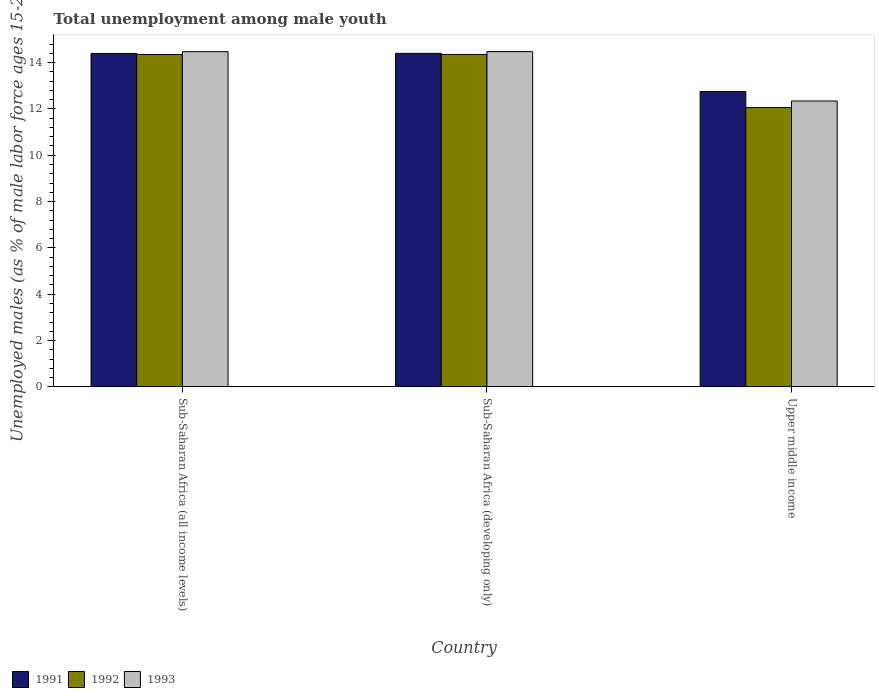How many groups of bars are there?
Your answer should be very brief. 3. How many bars are there on the 2nd tick from the right?
Your answer should be very brief. 3. What is the label of the 2nd group of bars from the left?
Your answer should be compact. Sub-Saharan Africa (developing only). In how many cases, is the number of bars for a given country not equal to the number of legend labels?
Give a very brief answer. 0. What is the percentage of unemployed males in in 1993 in Sub-Saharan Africa (developing only)?
Ensure brevity in your answer.  14.47. Across all countries, what is the maximum percentage of unemployed males in in 1991?
Your answer should be very brief. 14.4. Across all countries, what is the minimum percentage of unemployed males in in 1991?
Offer a terse response. 12.75. In which country was the percentage of unemployed males in in 1992 maximum?
Your answer should be compact. Sub-Saharan Africa (developing only). In which country was the percentage of unemployed males in in 1992 minimum?
Your answer should be very brief. Upper middle income. What is the total percentage of unemployed males in in 1991 in the graph?
Offer a very short reply. 41.55. What is the difference between the percentage of unemployed males in in 1993 in Sub-Saharan Africa (all income levels) and that in Upper middle income?
Make the answer very short. 2.13. What is the difference between the percentage of unemployed males in in 1993 in Sub-Saharan Africa (developing only) and the percentage of unemployed males in in 1991 in Upper middle income?
Provide a succinct answer. 1.72. What is the average percentage of unemployed males in in 1991 per country?
Offer a terse response. 13.85. What is the difference between the percentage of unemployed males in of/in 1993 and percentage of unemployed males in of/in 1992 in Sub-Saharan Africa (developing only)?
Your answer should be compact. 0.12. What is the ratio of the percentage of unemployed males in in 1992 in Sub-Saharan Africa (developing only) to that in Upper middle income?
Make the answer very short. 1.19. Is the percentage of unemployed males in in 1991 in Sub-Saharan Africa (all income levels) less than that in Sub-Saharan Africa (developing only)?
Make the answer very short. Yes. Is the difference between the percentage of unemployed males in in 1993 in Sub-Saharan Africa (all income levels) and Upper middle income greater than the difference between the percentage of unemployed males in in 1992 in Sub-Saharan Africa (all income levels) and Upper middle income?
Your answer should be very brief. No. What is the difference between the highest and the second highest percentage of unemployed males in in 1991?
Your response must be concise. -1.65. What is the difference between the highest and the lowest percentage of unemployed males in in 1991?
Provide a short and direct response. 1.65. In how many countries, is the percentage of unemployed males in in 1993 greater than the average percentage of unemployed males in in 1993 taken over all countries?
Keep it short and to the point. 2. Is the sum of the percentage of unemployed males in in 1991 in Sub-Saharan Africa (developing only) and Upper middle income greater than the maximum percentage of unemployed males in in 1993 across all countries?
Make the answer very short. Yes. Are all the bars in the graph horizontal?
Make the answer very short. No. What is the difference between two consecutive major ticks on the Y-axis?
Ensure brevity in your answer.  2. Does the graph contain any zero values?
Offer a very short reply. No. Does the graph contain grids?
Give a very brief answer. No. Where does the legend appear in the graph?
Ensure brevity in your answer.  Bottom left. How are the legend labels stacked?
Keep it short and to the point. Horizontal. What is the title of the graph?
Your response must be concise. Total unemployment among male youth. What is the label or title of the X-axis?
Give a very brief answer. Country. What is the label or title of the Y-axis?
Give a very brief answer. Unemployed males (as % of male labor force ages 15-24). What is the Unemployed males (as % of male labor force ages 15-24) in 1991 in Sub-Saharan Africa (all income levels)?
Offer a very short reply. 14.4. What is the Unemployed males (as % of male labor force ages 15-24) in 1992 in Sub-Saharan Africa (all income levels)?
Provide a short and direct response. 14.35. What is the Unemployed males (as % of male labor force ages 15-24) in 1993 in Sub-Saharan Africa (all income levels)?
Ensure brevity in your answer.  14.47. What is the Unemployed males (as % of male labor force ages 15-24) in 1991 in Sub-Saharan Africa (developing only)?
Ensure brevity in your answer.  14.4. What is the Unemployed males (as % of male labor force ages 15-24) of 1992 in Sub-Saharan Africa (developing only)?
Give a very brief answer. 14.35. What is the Unemployed males (as % of male labor force ages 15-24) in 1993 in Sub-Saharan Africa (developing only)?
Offer a very short reply. 14.47. What is the Unemployed males (as % of male labor force ages 15-24) in 1991 in Upper middle income?
Provide a short and direct response. 12.75. What is the Unemployed males (as % of male labor force ages 15-24) of 1992 in Upper middle income?
Give a very brief answer. 12.06. What is the Unemployed males (as % of male labor force ages 15-24) of 1993 in Upper middle income?
Your answer should be very brief. 12.34. Across all countries, what is the maximum Unemployed males (as % of male labor force ages 15-24) in 1991?
Your answer should be compact. 14.4. Across all countries, what is the maximum Unemployed males (as % of male labor force ages 15-24) in 1992?
Offer a terse response. 14.35. Across all countries, what is the maximum Unemployed males (as % of male labor force ages 15-24) of 1993?
Keep it short and to the point. 14.47. Across all countries, what is the minimum Unemployed males (as % of male labor force ages 15-24) of 1991?
Make the answer very short. 12.75. Across all countries, what is the minimum Unemployed males (as % of male labor force ages 15-24) of 1992?
Your response must be concise. 12.06. Across all countries, what is the minimum Unemployed males (as % of male labor force ages 15-24) of 1993?
Make the answer very short. 12.34. What is the total Unemployed males (as % of male labor force ages 15-24) in 1991 in the graph?
Offer a very short reply. 41.55. What is the total Unemployed males (as % of male labor force ages 15-24) of 1992 in the graph?
Provide a short and direct response. 40.76. What is the total Unemployed males (as % of male labor force ages 15-24) of 1993 in the graph?
Your answer should be compact. 41.29. What is the difference between the Unemployed males (as % of male labor force ages 15-24) in 1991 in Sub-Saharan Africa (all income levels) and that in Sub-Saharan Africa (developing only)?
Keep it short and to the point. -0. What is the difference between the Unemployed males (as % of male labor force ages 15-24) in 1992 in Sub-Saharan Africa (all income levels) and that in Sub-Saharan Africa (developing only)?
Keep it short and to the point. -0. What is the difference between the Unemployed males (as % of male labor force ages 15-24) in 1993 in Sub-Saharan Africa (all income levels) and that in Sub-Saharan Africa (developing only)?
Provide a short and direct response. -0. What is the difference between the Unemployed males (as % of male labor force ages 15-24) in 1991 in Sub-Saharan Africa (all income levels) and that in Upper middle income?
Offer a very short reply. 1.65. What is the difference between the Unemployed males (as % of male labor force ages 15-24) of 1992 in Sub-Saharan Africa (all income levels) and that in Upper middle income?
Provide a short and direct response. 2.29. What is the difference between the Unemployed males (as % of male labor force ages 15-24) of 1993 in Sub-Saharan Africa (all income levels) and that in Upper middle income?
Offer a very short reply. 2.13. What is the difference between the Unemployed males (as % of male labor force ages 15-24) in 1991 in Sub-Saharan Africa (developing only) and that in Upper middle income?
Provide a short and direct response. 1.65. What is the difference between the Unemployed males (as % of male labor force ages 15-24) in 1992 in Sub-Saharan Africa (developing only) and that in Upper middle income?
Provide a succinct answer. 2.29. What is the difference between the Unemployed males (as % of male labor force ages 15-24) in 1993 in Sub-Saharan Africa (developing only) and that in Upper middle income?
Make the answer very short. 2.13. What is the difference between the Unemployed males (as % of male labor force ages 15-24) in 1991 in Sub-Saharan Africa (all income levels) and the Unemployed males (as % of male labor force ages 15-24) in 1992 in Sub-Saharan Africa (developing only)?
Your answer should be very brief. 0.04. What is the difference between the Unemployed males (as % of male labor force ages 15-24) in 1991 in Sub-Saharan Africa (all income levels) and the Unemployed males (as % of male labor force ages 15-24) in 1993 in Sub-Saharan Africa (developing only)?
Provide a short and direct response. -0.08. What is the difference between the Unemployed males (as % of male labor force ages 15-24) of 1992 in Sub-Saharan Africa (all income levels) and the Unemployed males (as % of male labor force ages 15-24) of 1993 in Sub-Saharan Africa (developing only)?
Provide a short and direct response. -0.12. What is the difference between the Unemployed males (as % of male labor force ages 15-24) in 1991 in Sub-Saharan Africa (all income levels) and the Unemployed males (as % of male labor force ages 15-24) in 1992 in Upper middle income?
Ensure brevity in your answer.  2.34. What is the difference between the Unemployed males (as % of male labor force ages 15-24) in 1991 in Sub-Saharan Africa (all income levels) and the Unemployed males (as % of male labor force ages 15-24) in 1993 in Upper middle income?
Make the answer very short. 2.05. What is the difference between the Unemployed males (as % of male labor force ages 15-24) of 1992 in Sub-Saharan Africa (all income levels) and the Unemployed males (as % of male labor force ages 15-24) of 1993 in Upper middle income?
Keep it short and to the point. 2.01. What is the difference between the Unemployed males (as % of male labor force ages 15-24) in 1991 in Sub-Saharan Africa (developing only) and the Unemployed males (as % of male labor force ages 15-24) in 1992 in Upper middle income?
Provide a short and direct response. 2.34. What is the difference between the Unemployed males (as % of male labor force ages 15-24) in 1991 in Sub-Saharan Africa (developing only) and the Unemployed males (as % of male labor force ages 15-24) in 1993 in Upper middle income?
Offer a very short reply. 2.06. What is the difference between the Unemployed males (as % of male labor force ages 15-24) of 1992 in Sub-Saharan Africa (developing only) and the Unemployed males (as % of male labor force ages 15-24) of 1993 in Upper middle income?
Your response must be concise. 2.01. What is the average Unemployed males (as % of male labor force ages 15-24) in 1991 per country?
Make the answer very short. 13.85. What is the average Unemployed males (as % of male labor force ages 15-24) of 1992 per country?
Keep it short and to the point. 13.59. What is the average Unemployed males (as % of male labor force ages 15-24) of 1993 per country?
Provide a short and direct response. 13.76. What is the difference between the Unemployed males (as % of male labor force ages 15-24) of 1991 and Unemployed males (as % of male labor force ages 15-24) of 1992 in Sub-Saharan Africa (all income levels)?
Give a very brief answer. 0.05. What is the difference between the Unemployed males (as % of male labor force ages 15-24) in 1991 and Unemployed males (as % of male labor force ages 15-24) in 1993 in Sub-Saharan Africa (all income levels)?
Provide a short and direct response. -0.08. What is the difference between the Unemployed males (as % of male labor force ages 15-24) in 1992 and Unemployed males (as % of male labor force ages 15-24) in 1993 in Sub-Saharan Africa (all income levels)?
Your response must be concise. -0.12. What is the difference between the Unemployed males (as % of male labor force ages 15-24) of 1991 and Unemployed males (as % of male labor force ages 15-24) of 1992 in Sub-Saharan Africa (developing only)?
Keep it short and to the point. 0.05. What is the difference between the Unemployed males (as % of male labor force ages 15-24) in 1991 and Unemployed males (as % of male labor force ages 15-24) in 1993 in Sub-Saharan Africa (developing only)?
Make the answer very short. -0.07. What is the difference between the Unemployed males (as % of male labor force ages 15-24) in 1992 and Unemployed males (as % of male labor force ages 15-24) in 1993 in Sub-Saharan Africa (developing only)?
Give a very brief answer. -0.12. What is the difference between the Unemployed males (as % of male labor force ages 15-24) of 1991 and Unemployed males (as % of male labor force ages 15-24) of 1992 in Upper middle income?
Offer a very short reply. 0.69. What is the difference between the Unemployed males (as % of male labor force ages 15-24) of 1991 and Unemployed males (as % of male labor force ages 15-24) of 1993 in Upper middle income?
Your answer should be very brief. 0.41. What is the difference between the Unemployed males (as % of male labor force ages 15-24) of 1992 and Unemployed males (as % of male labor force ages 15-24) of 1993 in Upper middle income?
Your response must be concise. -0.28. What is the ratio of the Unemployed males (as % of male labor force ages 15-24) in 1991 in Sub-Saharan Africa (all income levels) to that in Sub-Saharan Africa (developing only)?
Keep it short and to the point. 1. What is the ratio of the Unemployed males (as % of male labor force ages 15-24) of 1992 in Sub-Saharan Africa (all income levels) to that in Sub-Saharan Africa (developing only)?
Provide a succinct answer. 1. What is the ratio of the Unemployed males (as % of male labor force ages 15-24) in 1991 in Sub-Saharan Africa (all income levels) to that in Upper middle income?
Offer a very short reply. 1.13. What is the ratio of the Unemployed males (as % of male labor force ages 15-24) in 1992 in Sub-Saharan Africa (all income levels) to that in Upper middle income?
Provide a short and direct response. 1.19. What is the ratio of the Unemployed males (as % of male labor force ages 15-24) in 1993 in Sub-Saharan Africa (all income levels) to that in Upper middle income?
Offer a very short reply. 1.17. What is the ratio of the Unemployed males (as % of male labor force ages 15-24) in 1991 in Sub-Saharan Africa (developing only) to that in Upper middle income?
Offer a very short reply. 1.13. What is the ratio of the Unemployed males (as % of male labor force ages 15-24) of 1992 in Sub-Saharan Africa (developing only) to that in Upper middle income?
Provide a short and direct response. 1.19. What is the ratio of the Unemployed males (as % of male labor force ages 15-24) in 1993 in Sub-Saharan Africa (developing only) to that in Upper middle income?
Your answer should be compact. 1.17. What is the difference between the highest and the second highest Unemployed males (as % of male labor force ages 15-24) of 1991?
Your answer should be compact. 0. What is the difference between the highest and the second highest Unemployed males (as % of male labor force ages 15-24) in 1992?
Give a very brief answer. 0. What is the difference between the highest and the second highest Unemployed males (as % of male labor force ages 15-24) of 1993?
Keep it short and to the point. 0. What is the difference between the highest and the lowest Unemployed males (as % of male labor force ages 15-24) of 1991?
Give a very brief answer. 1.65. What is the difference between the highest and the lowest Unemployed males (as % of male labor force ages 15-24) in 1992?
Your answer should be very brief. 2.29. What is the difference between the highest and the lowest Unemployed males (as % of male labor force ages 15-24) of 1993?
Make the answer very short. 2.13. 